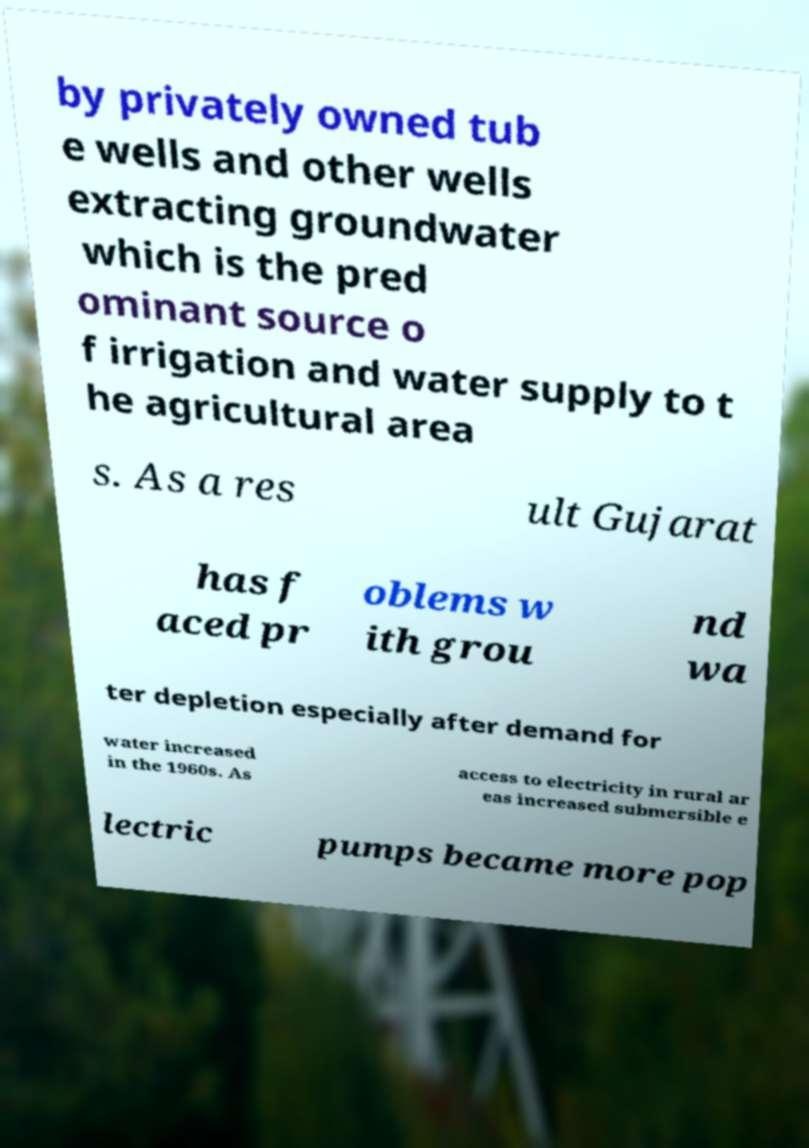Could you assist in decoding the text presented in this image and type it out clearly? by privately owned tub e wells and other wells extracting groundwater which is the pred ominant source o f irrigation and water supply to t he agricultural area s. As a res ult Gujarat has f aced pr oblems w ith grou nd wa ter depletion especially after demand for water increased in the 1960s. As access to electricity in rural ar eas increased submersible e lectric pumps became more pop 